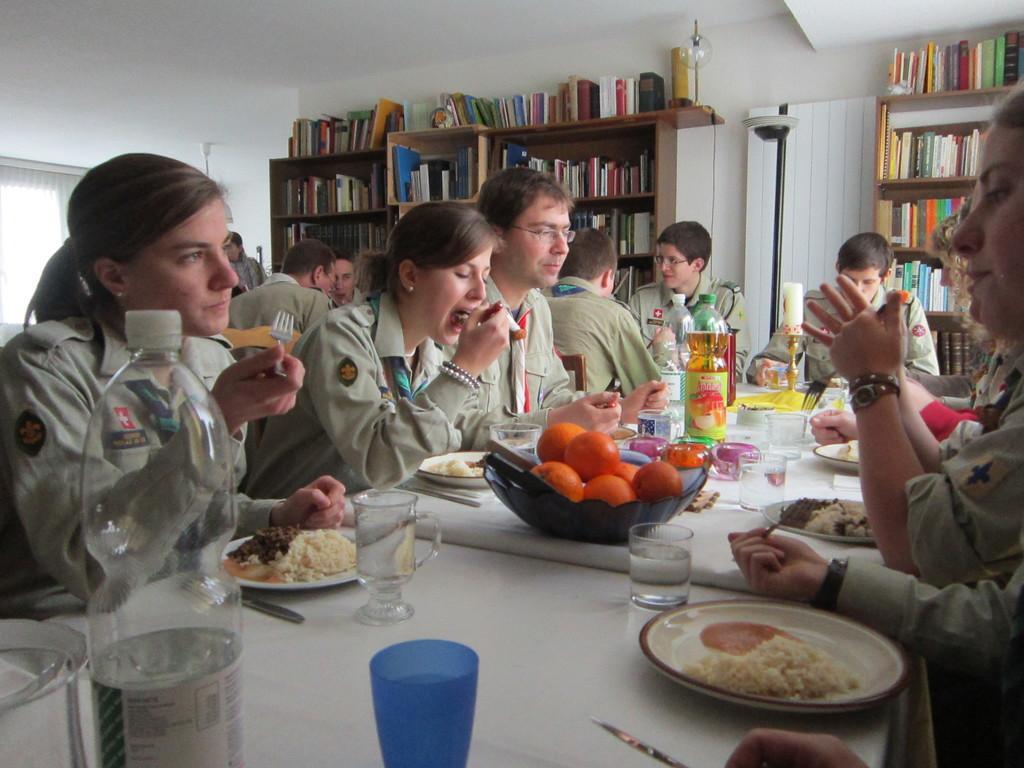How would you summarize this image in a sentence or two? In the image in the center we can see few people were sitting on the chair around the table and they were holding some objects. On the table,we can see plates,glasses,bowls,tissue papers,bottles,fruits,some food items and few other objects. In the background there is a wall,roof,bulb,lamp,window,curtain,rails,books and few people were sitting on the chair 